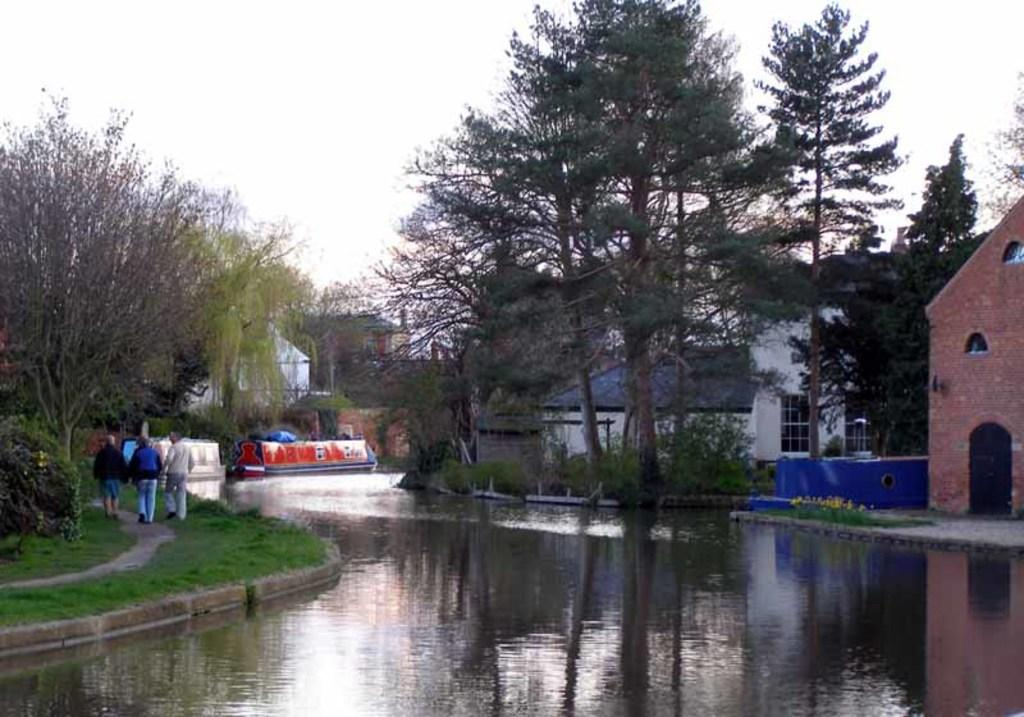What is visible in the image? Water is visible in the image. Where are the people located in the image? There are three people on the left side of the image. What can be seen in the background of the image? There are trees, buildings, and the sky visible in the background of the image. What type of copper material is being used by the people in the image? There is no copper material present in the image; it features water, people, trees, buildings, and the sky. What is the opinion of the trees about the buildings in the image? Trees do not have opinions, as they are inanimate objects. 